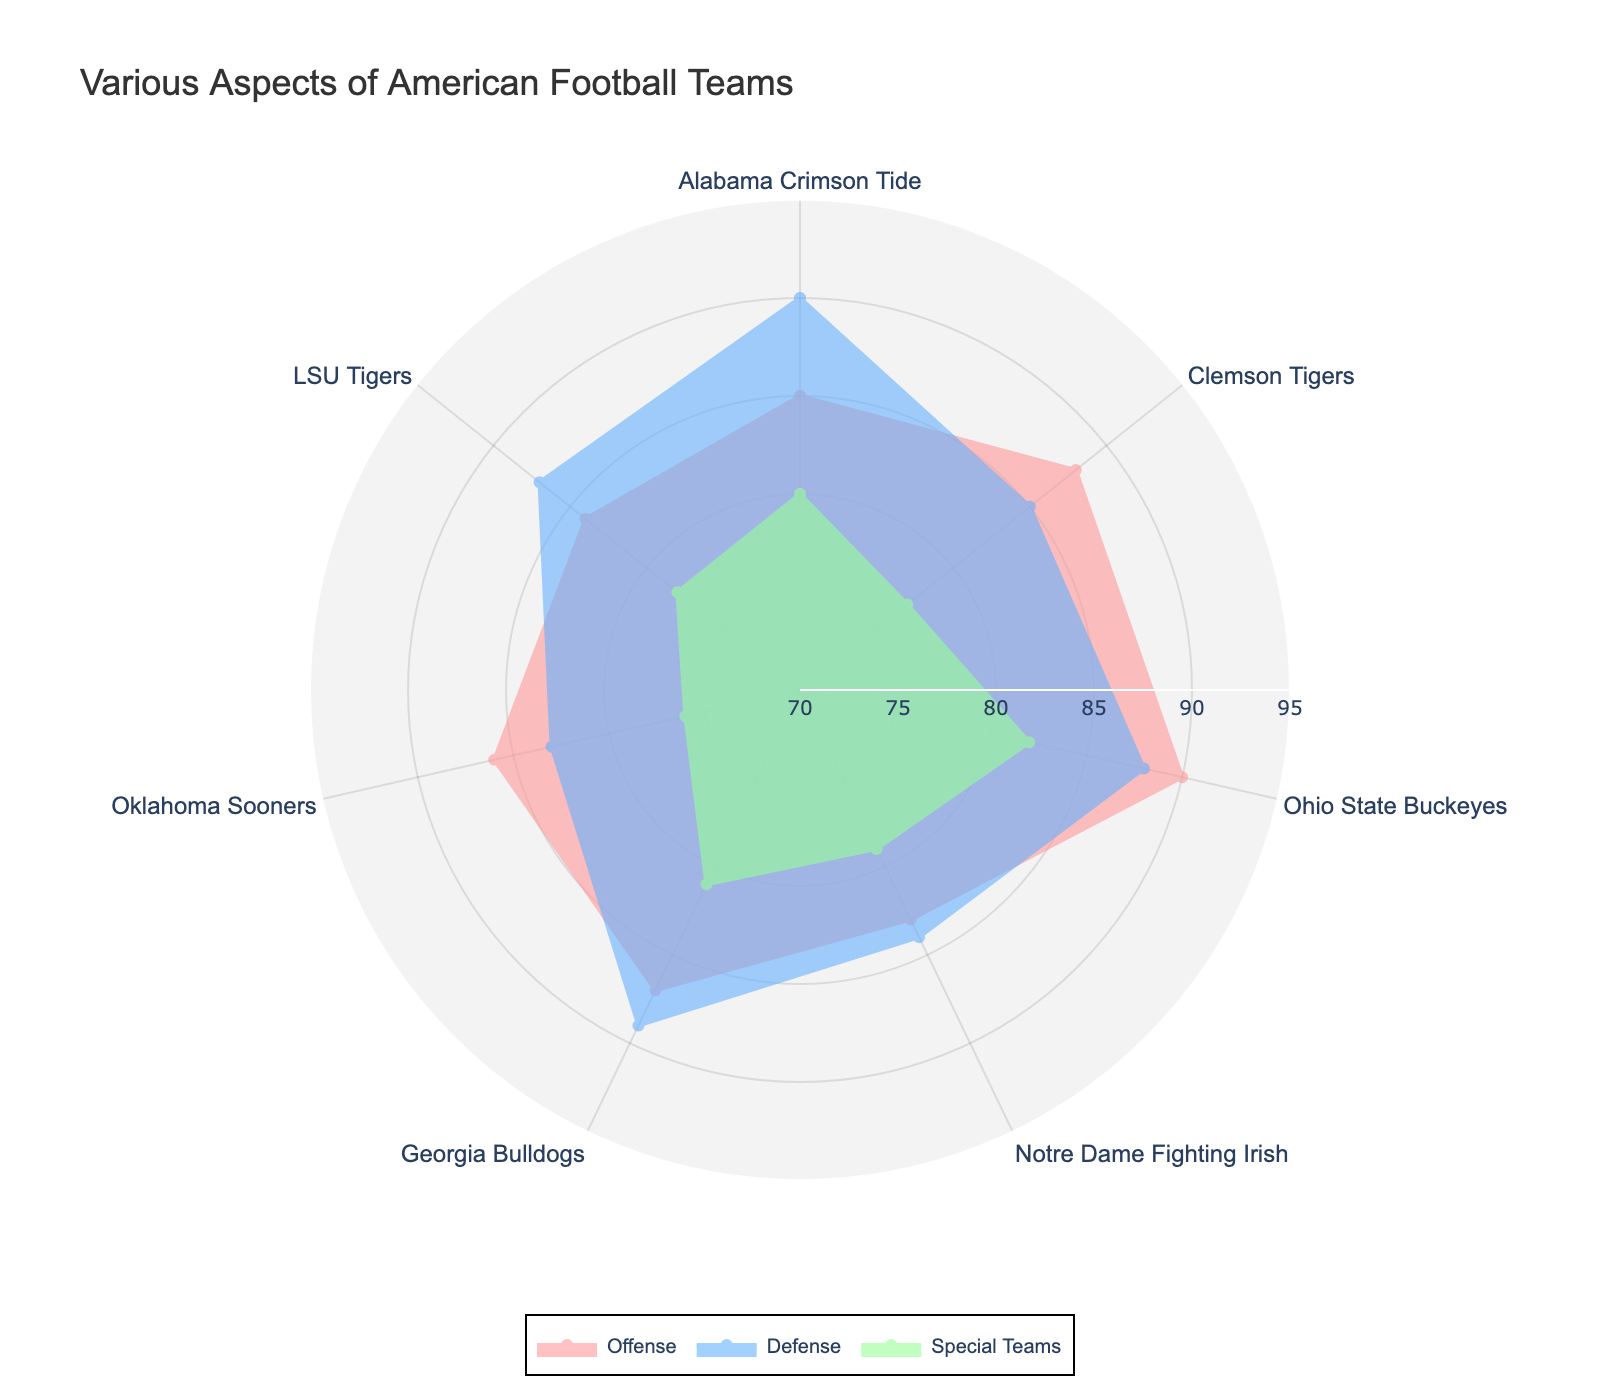what's the title of the radar chart? The title of the radar chart is displayed at the top, usually in a large font size.
Answer: Various Aspects of American Football Teams how many teams are included in the radar chart? Each polygon represents a different team, and there are different colors for each team. By counting the colored polygons or legends, you can see there are 7 teams.
Answer: 7 which team has the highest offensive score? After looking at the values along the "Offense" axis, the team with the highest position is Ohio State Buckeyes with a score of 90.
Answer: Ohio State Buckeyes what is the sum of the special teams' scores for Alabama Crimson Tide and Ohio State Buckeyes? Alabama Crimson Tide has a special teams score of 80, and Ohio State Buckeyes has a score of 82. Sum them up to get 80 + 82 = 162.
Answer: 162 which team has the lowest score in special teams, and what is the score? By comparing the values along the "Special Teams" axis, the lowest position corresponds to Oklahoma Sooners with a score of 76.
Answer: Oklahoma Sooners with 76 how does Notre Dame Fighting Irish's defense compare to Alabama Crimson Tide's defense? Notre Dame Fighting Irish has a defensive score of 84, while Alabama Crimson Tide has a defensive score of 90. Therefore, Alabama Crimson Tide has a better defense than Notre Dame Fighting Irish.
Answer: Alabama Crimson Tide's defense is better which team has the closest scores between offense and defense? By examining the differences between offense and defense scores for each team, the Ohio State Buckeyes have scores of 90 and 88, respectively, a difference of just 2 points.
Answer: Ohio State Buckeyes what's the average offensive score across all teams? Sum all the offensive scores and divide by the number of teams. The scores are 85, 88, 90, 83, 87, 86, and 84. Sum these to get 603 and divide by 7, resulting in approximately 86.14.
Answer: 86.14 which team shows the highest variance in their ratings across all categories? The variance is calculated as the difference between the highest and lowest values for each team. After calculating, LSU Tigers have the highest variance: 87 (defense) - 78 (special teams) = 9.
Answer: LSU Tigers with a variance of 9 which two teams have the closest total scores across all categories, and what are those scores? Calculate the sum of offense, defense, and special teams for each team. Alabama Crimson Tide: 85+90+80=255, Clemson Tigers: 88+85+77=250, Ohio State Buckeyes: 90+88+82=260, Notre Dame Fighting Irish: 83+84+79=246, Georgia Bulldogs: 87+89+81=257, Oklahoma Sooners: 86+83+76=245, LSU Tigers: 84+87+78=249. Closest sums are Clemson Tigers (250) and LSU Tigers (249).
Answer: Clemson Tigers (250) and LSU Tigers (249) 